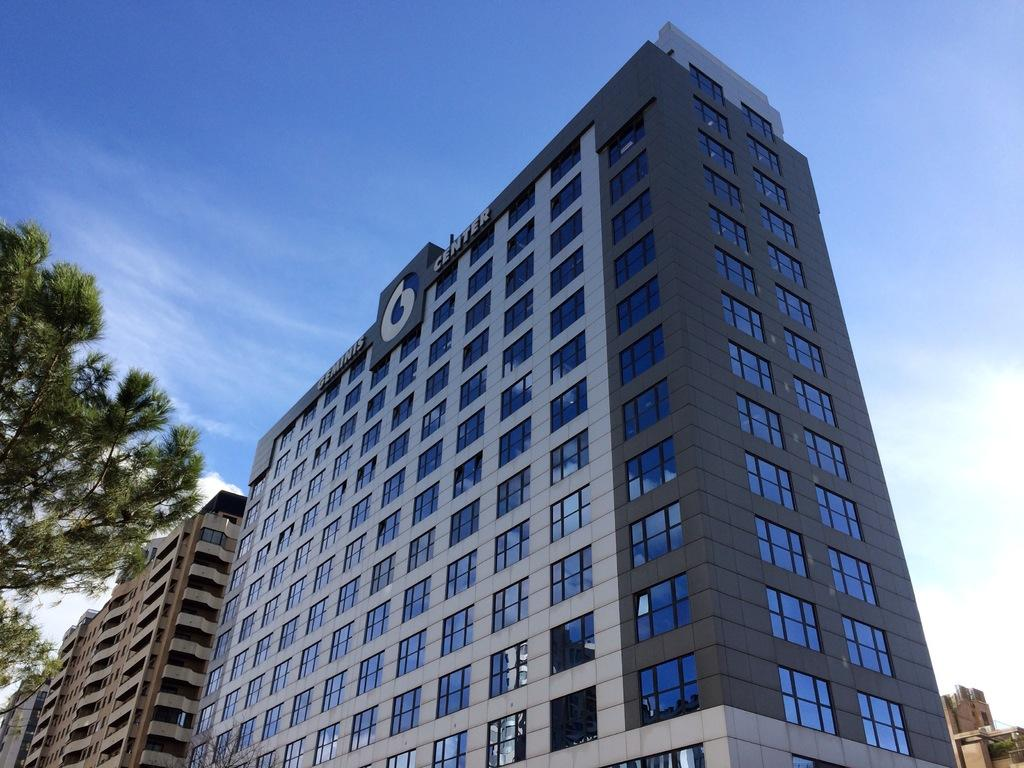What type of structures can be seen in the image? There are buildings in the image. Can you describe the colors of the buildings? The buildings have various colors, including white, black, blue, and brown. What else can be seen in the image besides buildings? There are trees in the image. Are there any other buildings visible in the image? Yes, there are other buildings in the image. What is visible in the background of the image? The sky is visible in the background of the image. What type of pollution can be seen in the image? There is no pollution visible in the image; it only shows buildings, trees, and the sky. What type of feast is being held in the image? There is no feast present in the image; it only shows buildings, trees, and the sky. 